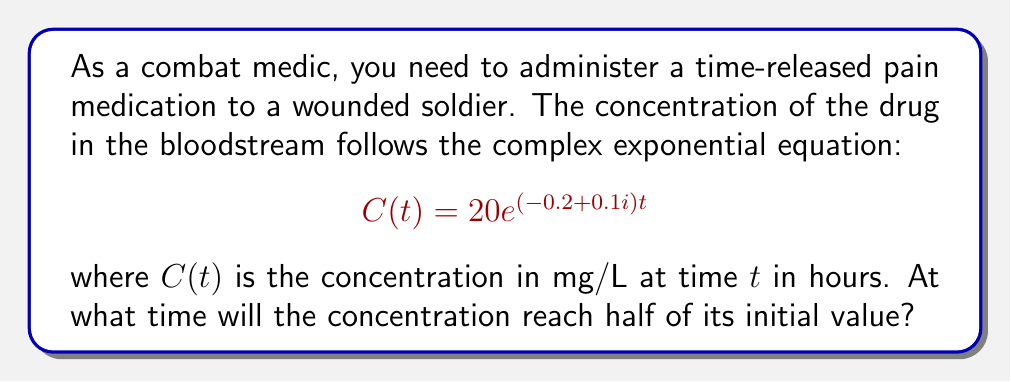Show me your answer to this math problem. To solve this problem, we need to follow these steps:

1) The initial concentration is when $t=0$:
   $$C(0) = 20e^{(-0.2+0.1i)(0)} = 20$$

2) We want to find $t$ when $C(t) = 10$ (half of the initial value):
   $$10 = 20e^{(-0.2+0.1i)t}$$

3) Divide both sides by 20:
   $$\frac{1}{2} = e^{(-0.2+0.1i)t}$$

4) Take the natural log of both sides:
   $$\ln(\frac{1}{2}) = (-0.2+0.1i)t$$

5) Solve for $t$:
   $$t = \frac{\ln(\frac{1}{2})}{-0.2+0.1i}$$

6) Simplify $\ln(\frac{1}{2}) = -\ln(2)$:
   $$t = \frac{-\ln(2)}{-0.2+0.1i}$$

7) Multiply numerator and denominator by the complex conjugate of the denominator:
   $$t = \frac{-\ln(2)(-0.2-0.1i)}{(-0.2+0.1i)(-0.2-0.1i)} = \frac{-\ln(2)(-0.2-0.1i)}{0.04+0.01}$$

8) Simplify:
   $$t = \frac{0.2\ln(2)+0.1i\ln(2)}{0.05} = 4\ln(2) + 2i\ln(2)$$

9) The real part of this complex number is the actual time:
   $$t = 4\ln(2) \approx 2.77 \text{ hours}$$
Answer: The concentration will reach half of its initial value after approximately 2.77 hours. 